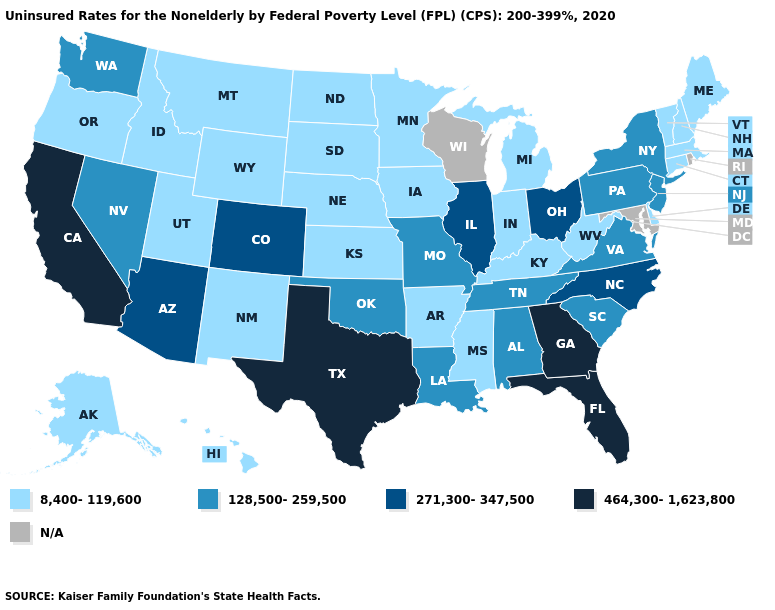What is the lowest value in states that border Oregon?
Quick response, please. 8,400-119,600. Name the states that have a value in the range 8,400-119,600?
Keep it brief. Alaska, Arkansas, Connecticut, Delaware, Hawaii, Idaho, Indiana, Iowa, Kansas, Kentucky, Maine, Massachusetts, Michigan, Minnesota, Mississippi, Montana, Nebraska, New Hampshire, New Mexico, North Dakota, Oregon, South Dakota, Utah, Vermont, West Virginia, Wyoming. Among the states that border South Carolina , which have the highest value?
Write a very short answer. Georgia. Among the states that border New York , which have the highest value?
Write a very short answer. New Jersey, Pennsylvania. What is the value of South Dakota?
Short answer required. 8,400-119,600. Does Pennsylvania have the highest value in the USA?
Short answer required. No. Name the states that have a value in the range 128,500-259,500?
Be succinct. Alabama, Louisiana, Missouri, Nevada, New Jersey, New York, Oklahoma, Pennsylvania, South Carolina, Tennessee, Virginia, Washington. What is the value of Delaware?
Keep it brief. 8,400-119,600. What is the value of Kansas?
Quick response, please. 8,400-119,600. Does the first symbol in the legend represent the smallest category?
Short answer required. Yes. Which states have the lowest value in the MidWest?
Quick response, please. Indiana, Iowa, Kansas, Michigan, Minnesota, Nebraska, North Dakota, South Dakota. What is the value of Connecticut?
Quick response, please. 8,400-119,600. Does the map have missing data?
Keep it brief. Yes. What is the value of Massachusetts?
Quick response, please. 8,400-119,600. What is the value of South Carolina?
Keep it brief. 128,500-259,500. 